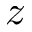Convert formula to latex. <formula><loc_0><loc_0><loc_500><loc_500>z</formula> 